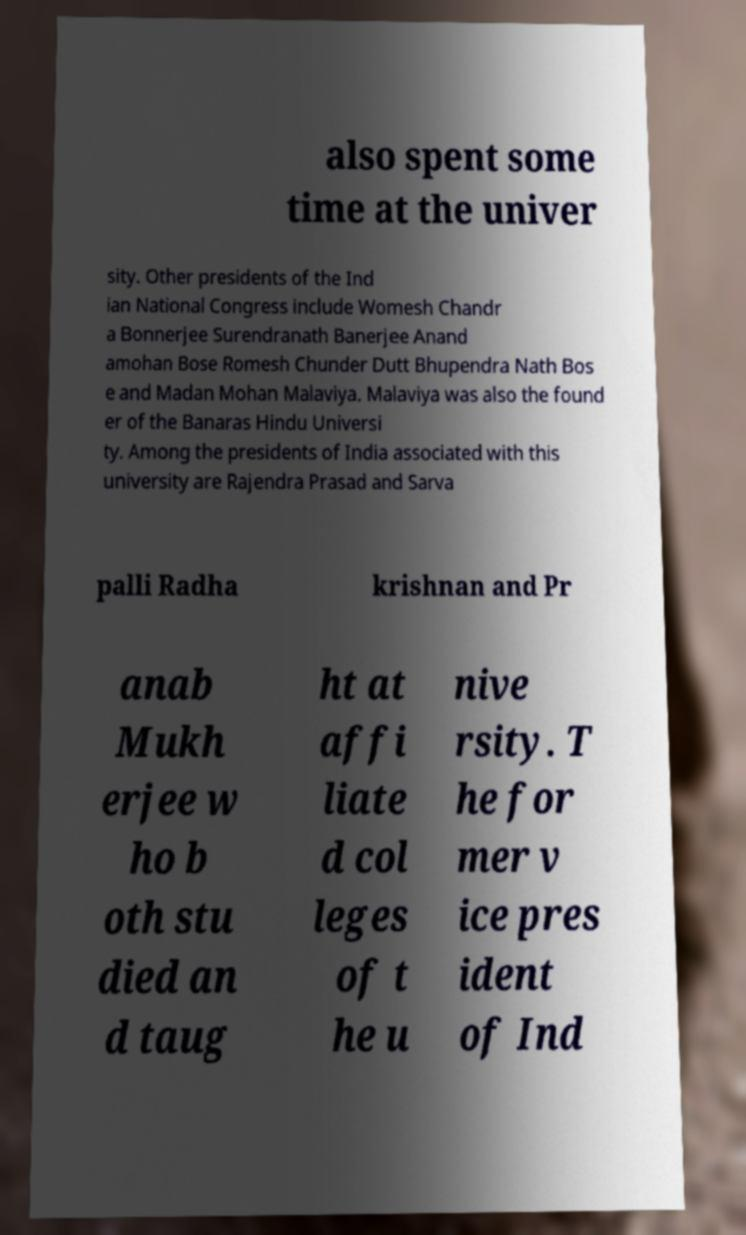Could you assist in decoding the text presented in this image and type it out clearly? also spent some time at the univer sity. Other presidents of the Ind ian National Congress include Womesh Chandr a Bonnerjee Surendranath Banerjee Anand amohan Bose Romesh Chunder Dutt Bhupendra Nath Bos e and Madan Mohan Malaviya. Malaviya was also the found er of the Banaras Hindu Universi ty. Among the presidents of India associated with this university are Rajendra Prasad and Sarva palli Radha krishnan and Pr anab Mukh erjee w ho b oth stu died an d taug ht at affi liate d col leges of t he u nive rsity. T he for mer v ice pres ident of Ind 